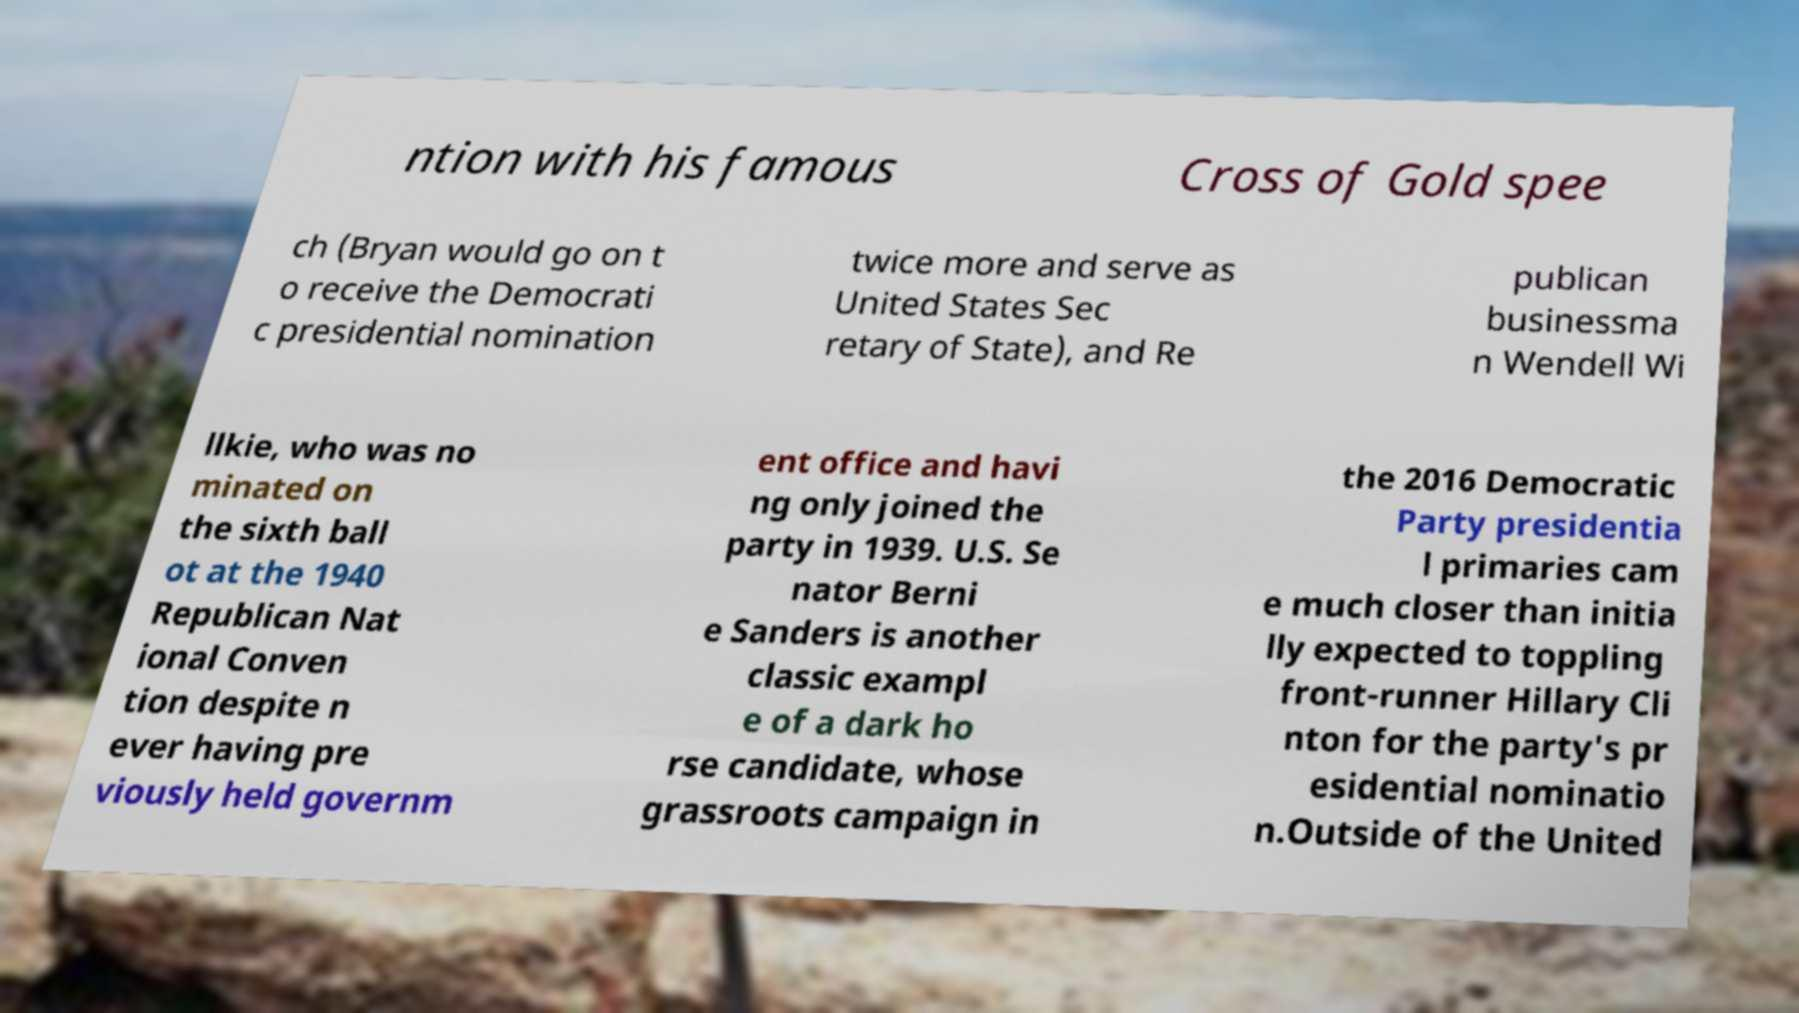Can you read and provide the text displayed in the image?This photo seems to have some interesting text. Can you extract and type it out for me? ntion with his famous Cross of Gold spee ch (Bryan would go on t o receive the Democrati c presidential nomination twice more and serve as United States Sec retary of State), and Re publican businessma n Wendell Wi llkie, who was no minated on the sixth ball ot at the 1940 Republican Nat ional Conven tion despite n ever having pre viously held governm ent office and havi ng only joined the party in 1939. U.S. Se nator Berni e Sanders is another classic exampl e of a dark ho rse candidate, whose grassroots campaign in the 2016 Democratic Party presidentia l primaries cam e much closer than initia lly expected to toppling front-runner Hillary Cli nton for the party's pr esidential nominatio n.Outside of the United 